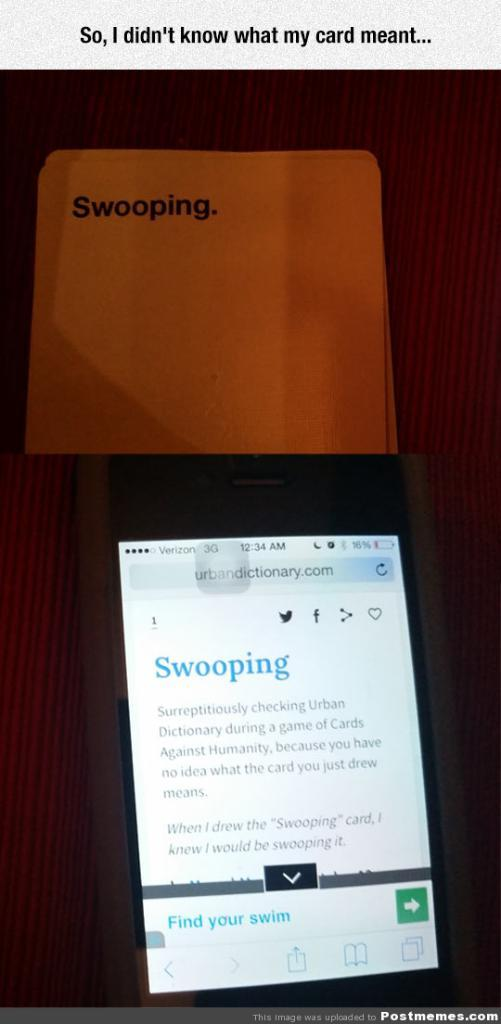<image>
Render a clear and concise summary of the photo. a poster says So I don't know what my card meant with a screen reading Swooping 